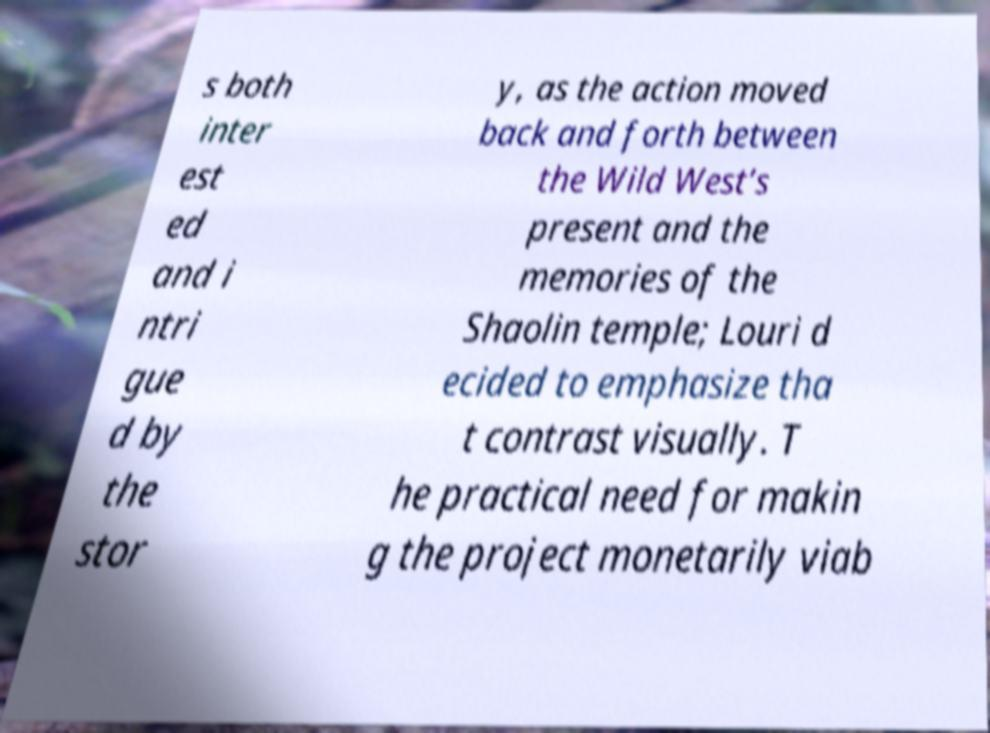For documentation purposes, I need the text within this image transcribed. Could you provide that? s both inter est ed and i ntri gue d by the stor y, as the action moved back and forth between the Wild West’s present and the memories of the Shaolin temple; Louri d ecided to emphasize tha t contrast visually. T he practical need for makin g the project monetarily viab 